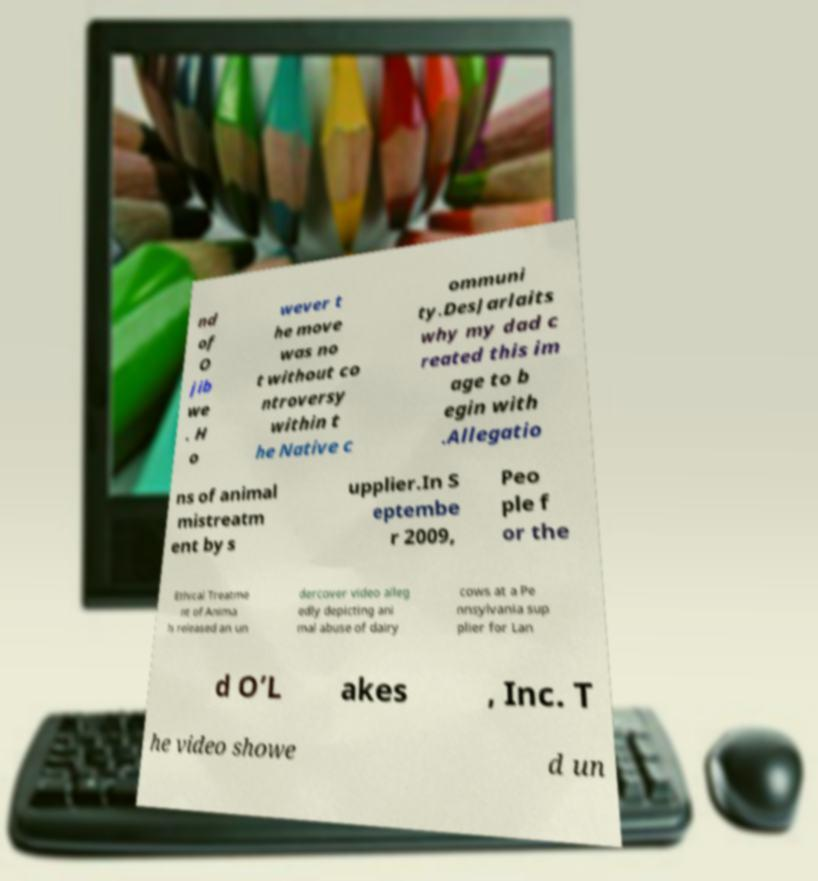There's text embedded in this image that I need extracted. Can you transcribe it verbatim? nd of O jib we . H o wever t he move was no t without co ntroversy within t he Native c ommuni ty.DesJarlaits why my dad c reated this im age to b egin with .Allegatio ns of animal mistreatm ent by s upplier.In S eptembe r 2009, Peo ple f or the Ethical Treatme nt of Anima ls released an un dercover video alleg edly depicting ani mal abuse of dairy cows at a Pe nnsylvania sup plier for Lan d O’L akes , Inc. T he video showe d un 